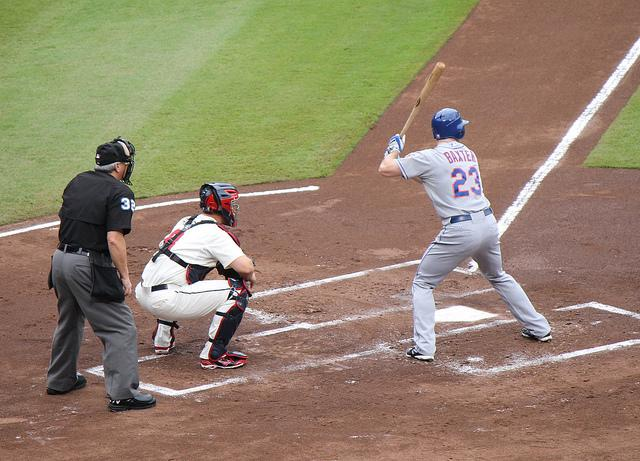Who is the away team?

Choices:
A) pirates
B) angels
C) mets
D) yankees yankees 